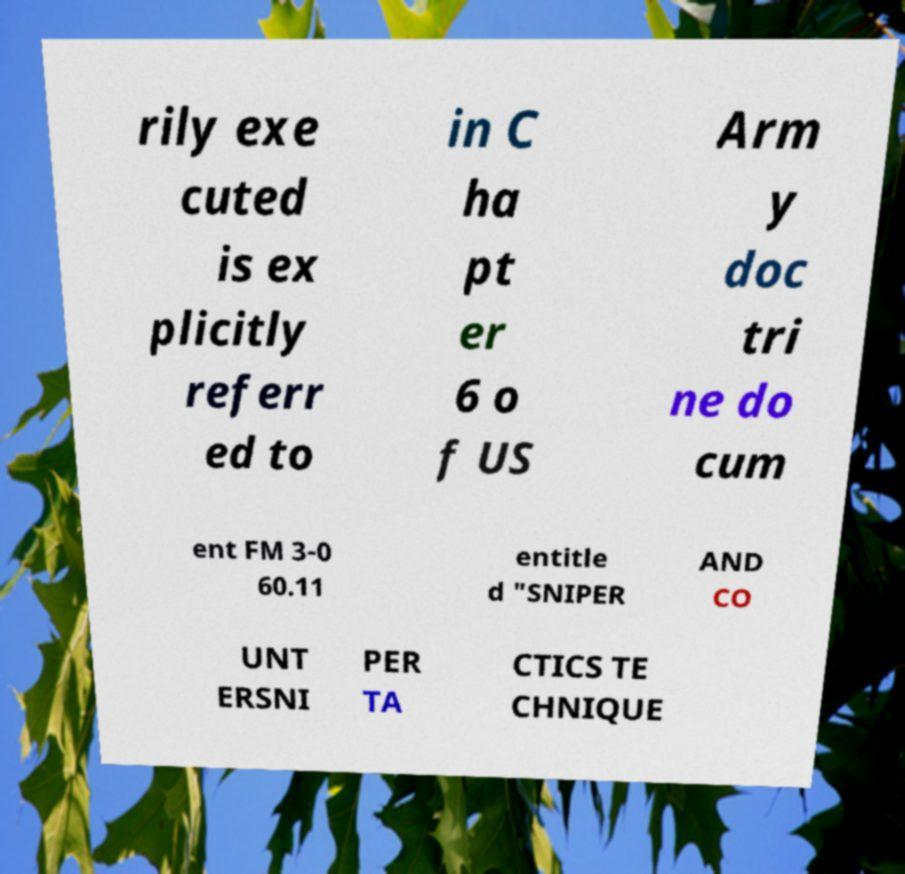Can you accurately transcribe the text from the provided image for me? rily exe cuted is ex plicitly referr ed to in C ha pt er 6 o f US Arm y doc tri ne do cum ent FM 3-0 60.11 entitle d "SNIPER AND CO UNT ERSNI PER TA CTICS TE CHNIQUE 